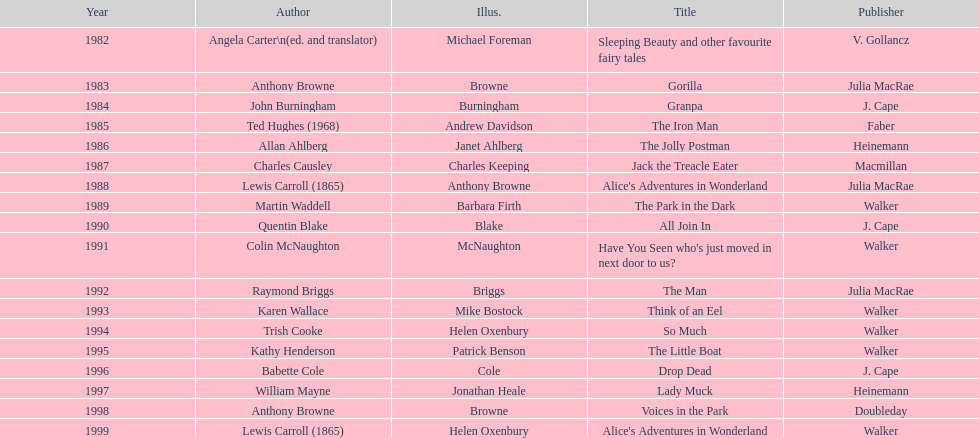What's the difference in years between angela carter's title and anthony browne's? 1. 